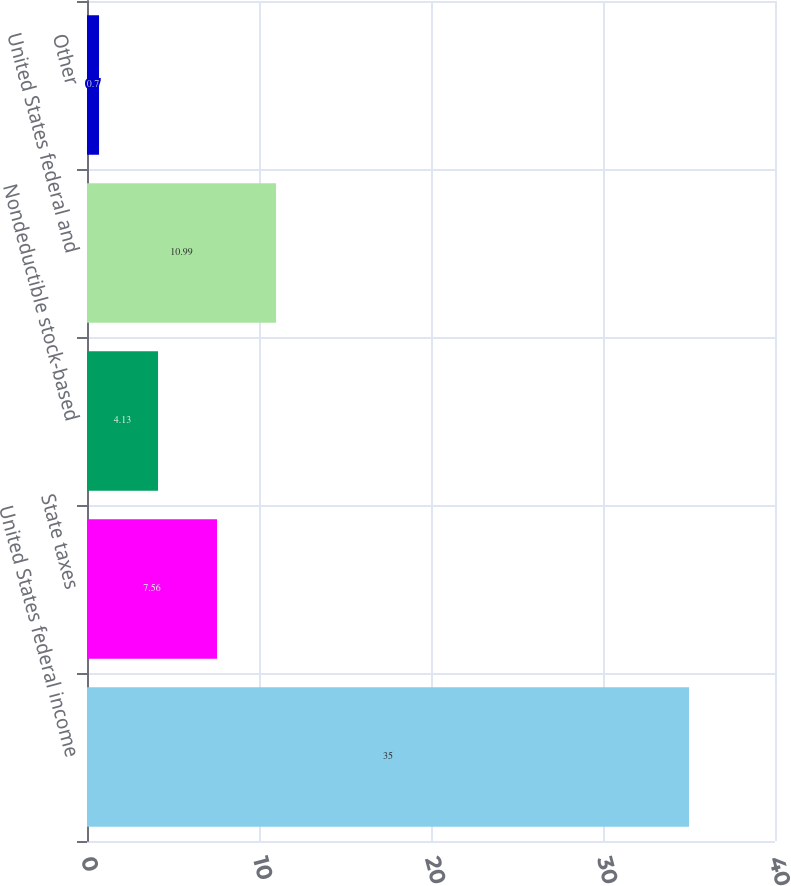Convert chart. <chart><loc_0><loc_0><loc_500><loc_500><bar_chart><fcel>United States federal income<fcel>State taxes<fcel>Nondeductible stock-based<fcel>United States federal and<fcel>Other<nl><fcel>35<fcel>7.56<fcel>4.13<fcel>10.99<fcel>0.7<nl></chart> 